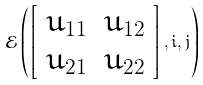<formula> <loc_0><loc_0><loc_500><loc_500>\mathcal { E } \left ( \left [ \begin{array} { c c c c } u _ { 1 1 } & u _ { 1 2 } \\ u _ { 2 1 } & u _ { 2 2 } \end{array} \right ] , i , j \right )</formula> 